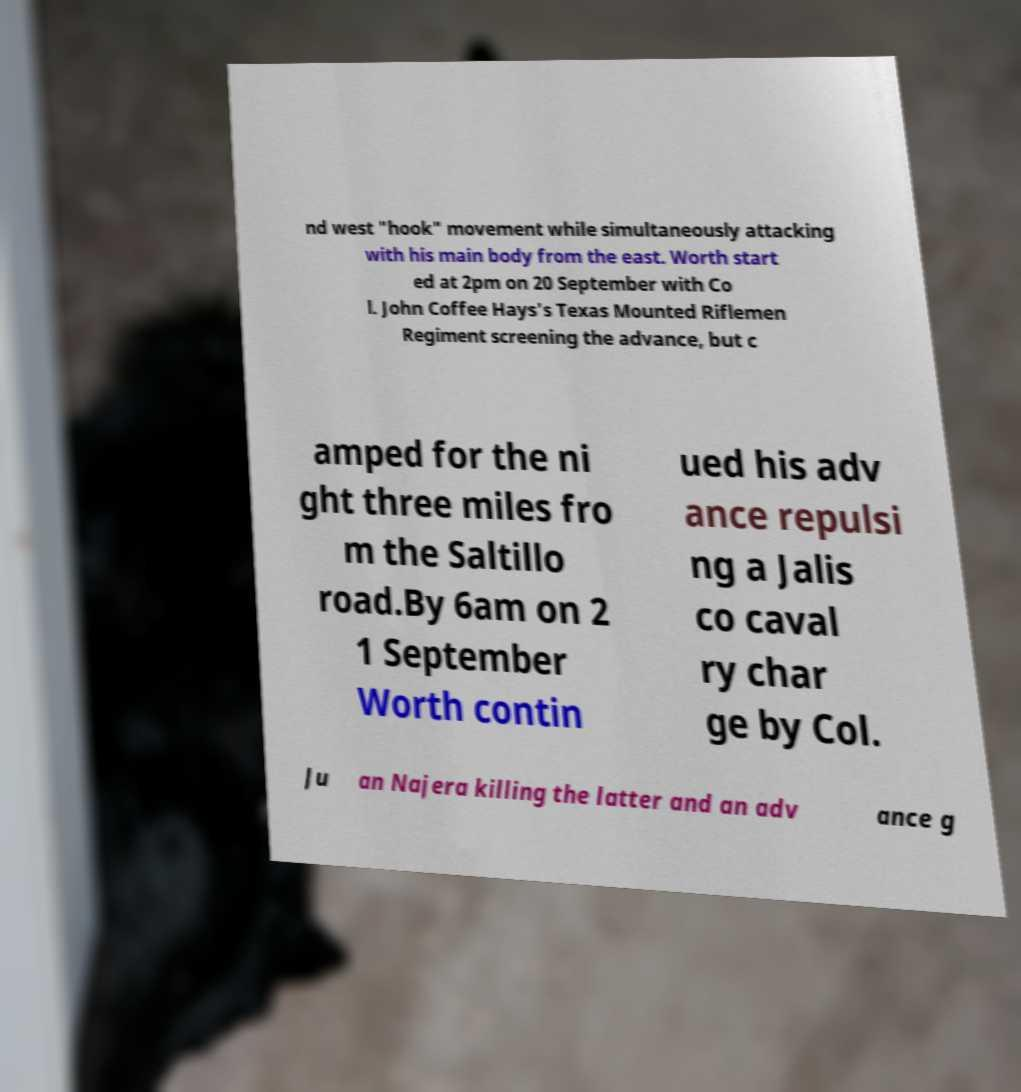What messages or text are displayed in this image? I need them in a readable, typed format. nd west "hook" movement while simultaneously attacking with his main body from the east. Worth start ed at 2pm on 20 September with Co l. John Coffee Hays's Texas Mounted Riflemen Regiment screening the advance, but c amped for the ni ght three miles fro m the Saltillo road.By 6am on 2 1 September Worth contin ued his adv ance repulsi ng a Jalis co caval ry char ge by Col. Ju an Najera killing the latter and an adv ance g 